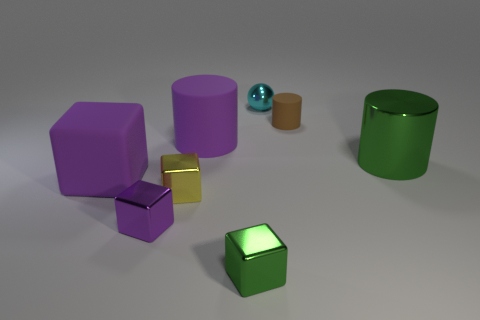Add 1 small brown metal blocks. How many objects exist? 9 Subtract all spheres. How many objects are left? 7 Add 8 cyan metal spheres. How many cyan metal spheres are left? 9 Add 1 tiny green balls. How many tiny green balls exist? 1 Subtract 0 blue blocks. How many objects are left? 8 Subtract all small purple objects. Subtract all small purple objects. How many objects are left? 6 